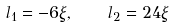<formula> <loc_0><loc_0><loc_500><loc_500>l _ { 1 } = - 6 \xi , \quad l _ { 2 } = 2 4 \xi</formula> 